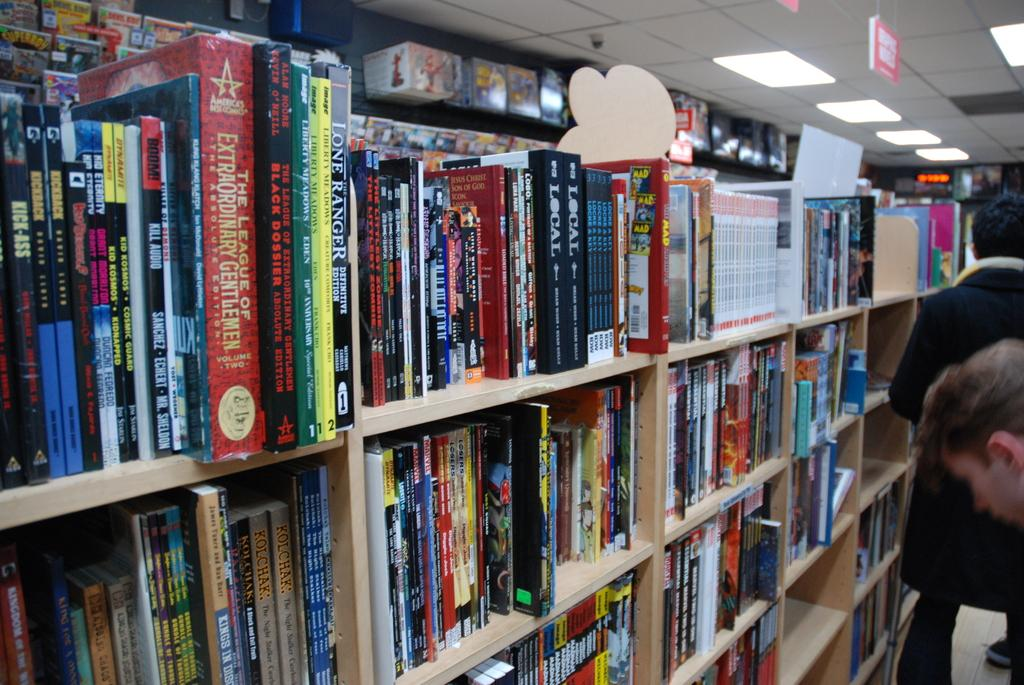<image>
Provide a brief description of the given image. Crowded bookshelves feature the League of Extraordinary Gentlemen and Local. 